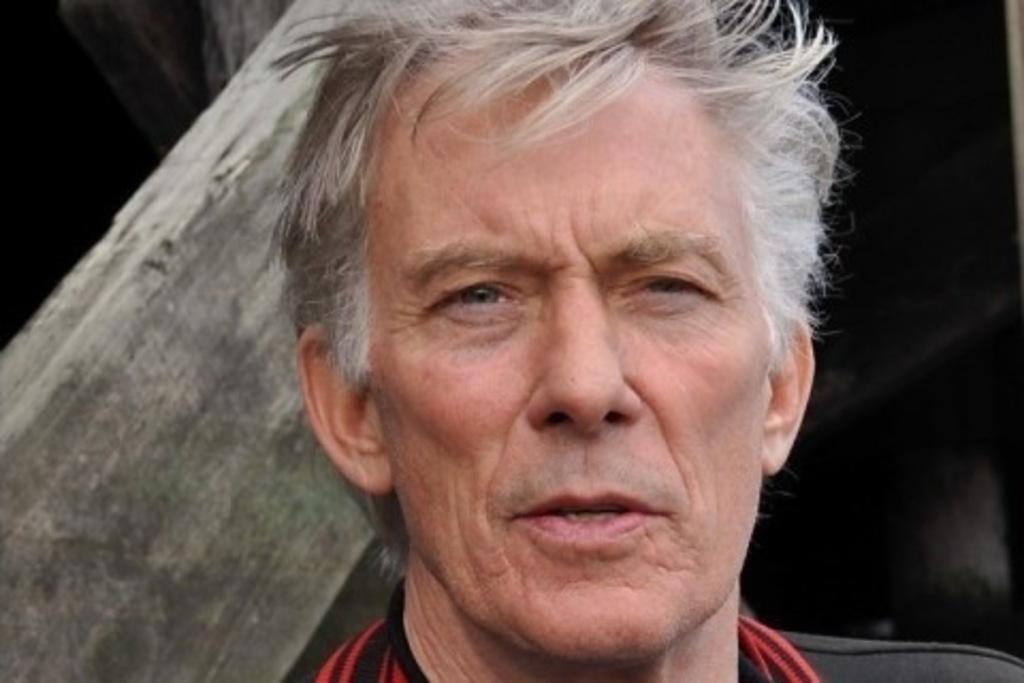What is the main subject of the image? The main subject of the image is a man's face. What can be seen on the left side of the image? There appears to be a pillar on the left side of the image. How would you describe the background of the image? The background of the image is dark. Can you see a frog jumping out of a hole in the image? No, there is no frog or hole present in the image. 